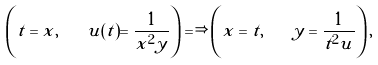Convert formula to latex. <formula><loc_0><loc_0><loc_500><loc_500>\left ( t = x , \quad u ( t ) = \frac { 1 } { x ^ { 2 } y } \right ) \Longrightarrow \left ( x = t , \quad y = \frac { 1 } { t ^ { 2 } u } \right ) ,</formula> 